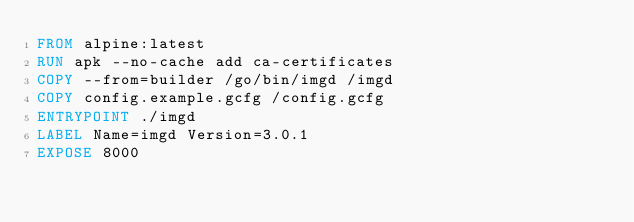Convert code to text. <code><loc_0><loc_0><loc_500><loc_500><_Dockerfile_>FROM alpine:latest
RUN apk --no-cache add ca-certificates
COPY --from=builder /go/bin/imgd /imgd
COPY config.example.gcfg /config.gcfg
ENTRYPOINT ./imgd
LABEL Name=imgd Version=3.0.1
EXPOSE 8000
</code> 